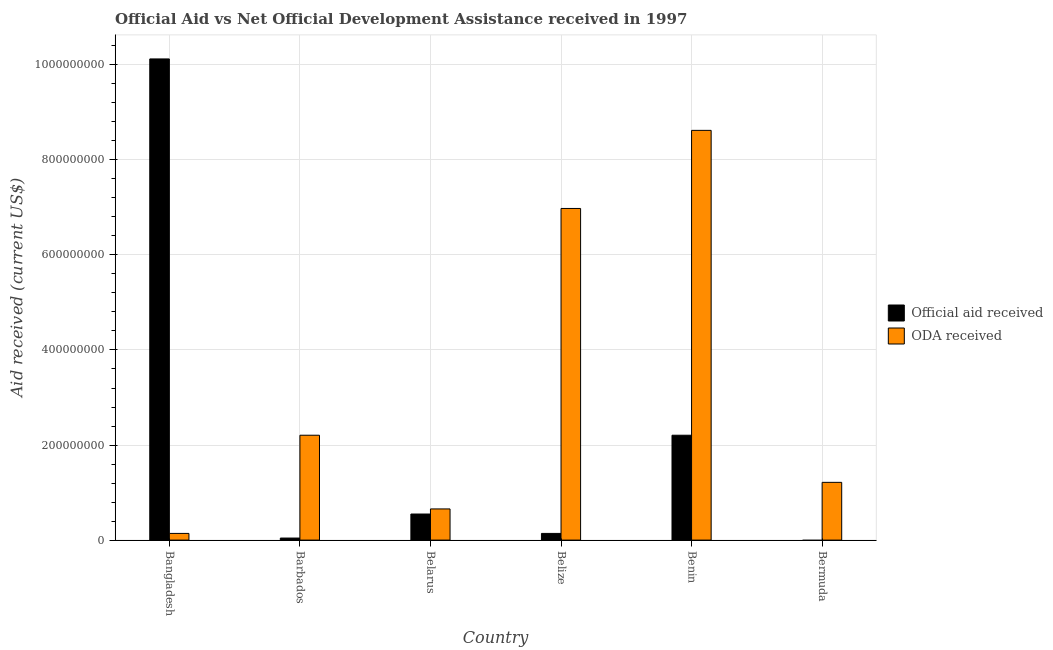How many different coloured bars are there?
Offer a terse response. 2. Are the number of bars per tick equal to the number of legend labels?
Make the answer very short. No. How many bars are there on the 1st tick from the left?
Make the answer very short. 2. How many bars are there on the 5th tick from the right?
Make the answer very short. 2. What is the label of the 4th group of bars from the left?
Give a very brief answer. Belize. What is the oda received in Bermuda?
Give a very brief answer. 1.22e+08. Across all countries, what is the maximum oda received?
Your answer should be very brief. 8.62e+08. What is the total official aid received in the graph?
Your answer should be very brief. 1.31e+09. What is the difference between the oda received in Barbados and that in Bermuda?
Your answer should be very brief. 9.92e+07. What is the difference between the official aid received in Belarus and the oda received in Belize?
Ensure brevity in your answer.  -6.43e+08. What is the average official aid received per country?
Give a very brief answer. 2.18e+08. What is the difference between the official aid received and oda received in Belarus?
Offer a very short reply. -1.07e+07. What is the ratio of the official aid received in Barbados to that in Benin?
Provide a short and direct response. 0.02. Is the oda received in Bangladesh less than that in Bermuda?
Offer a terse response. Yes. Is the difference between the official aid received in Barbados and Belarus greater than the difference between the oda received in Barbados and Belarus?
Provide a short and direct response. No. What is the difference between the highest and the second highest oda received?
Offer a very short reply. 1.64e+08. What is the difference between the highest and the lowest official aid received?
Your answer should be very brief. 1.01e+09. In how many countries, is the official aid received greater than the average official aid received taken over all countries?
Your answer should be very brief. 2. Is the sum of the oda received in Belize and Bermuda greater than the maximum official aid received across all countries?
Your answer should be very brief. No. How many bars are there?
Your response must be concise. 11. How many countries are there in the graph?
Your answer should be very brief. 6. Does the graph contain grids?
Ensure brevity in your answer.  Yes. Where does the legend appear in the graph?
Provide a succinct answer. Center right. How many legend labels are there?
Offer a very short reply. 2. What is the title of the graph?
Keep it short and to the point. Official Aid vs Net Official Development Assistance received in 1997 . Does "Under-5(male)" appear as one of the legend labels in the graph?
Give a very brief answer. No. What is the label or title of the Y-axis?
Ensure brevity in your answer.  Aid received (current US$). What is the Aid received (current US$) in Official aid received in Bangladesh?
Provide a short and direct response. 1.01e+09. What is the Aid received (current US$) of ODA received in Bangladesh?
Provide a short and direct response. 1.41e+07. What is the Aid received (current US$) of Official aid received in Barbados?
Provide a short and direct response. 4.32e+06. What is the Aid received (current US$) in ODA received in Barbados?
Keep it short and to the point. 2.21e+08. What is the Aid received (current US$) in Official aid received in Belarus?
Keep it short and to the point. 5.49e+07. What is the Aid received (current US$) of ODA received in Belarus?
Make the answer very short. 6.56e+07. What is the Aid received (current US$) of Official aid received in Belize?
Your answer should be compact. 1.41e+07. What is the Aid received (current US$) of ODA received in Belize?
Keep it short and to the point. 6.98e+08. What is the Aid received (current US$) of Official aid received in Benin?
Make the answer very short. 2.21e+08. What is the Aid received (current US$) in ODA received in Benin?
Offer a very short reply. 8.62e+08. What is the Aid received (current US$) of ODA received in Bermuda?
Keep it short and to the point. 1.22e+08. Across all countries, what is the maximum Aid received (current US$) of Official aid received?
Your response must be concise. 1.01e+09. Across all countries, what is the maximum Aid received (current US$) in ODA received?
Make the answer very short. 8.62e+08. Across all countries, what is the minimum Aid received (current US$) in ODA received?
Ensure brevity in your answer.  1.41e+07. What is the total Aid received (current US$) of Official aid received in the graph?
Make the answer very short. 1.31e+09. What is the total Aid received (current US$) of ODA received in the graph?
Give a very brief answer. 1.98e+09. What is the difference between the Aid received (current US$) of Official aid received in Bangladesh and that in Barbados?
Offer a very short reply. 1.01e+09. What is the difference between the Aid received (current US$) of ODA received in Bangladesh and that in Barbados?
Your answer should be very brief. -2.07e+08. What is the difference between the Aid received (current US$) in Official aid received in Bangladesh and that in Belarus?
Keep it short and to the point. 9.57e+08. What is the difference between the Aid received (current US$) of ODA received in Bangladesh and that in Belarus?
Your answer should be very brief. -5.15e+07. What is the difference between the Aid received (current US$) in Official aid received in Bangladesh and that in Belize?
Make the answer very short. 9.98e+08. What is the difference between the Aid received (current US$) of ODA received in Bangladesh and that in Belize?
Your answer should be very brief. -6.84e+08. What is the difference between the Aid received (current US$) of Official aid received in Bangladesh and that in Benin?
Provide a short and direct response. 7.92e+08. What is the difference between the Aid received (current US$) of ODA received in Bangladesh and that in Benin?
Provide a succinct answer. -8.48e+08. What is the difference between the Aid received (current US$) in ODA received in Bangladesh and that in Bermuda?
Your answer should be compact. -1.07e+08. What is the difference between the Aid received (current US$) in Official aid received in Barbados and that in Belarus?
Keep it short and to the point. -5.06e+07. What is the difference between the Aid received (current US$) of ODA received in Barbados and that in Belarus?
Your answer should be compact. 1.55e+08. What is the difference between the Aid received (current US$) of Official aid received in Barbados and that in Belize?
Give a very brief answer. -9.74e+06. What is the difference between the Aid received (current US$) in ODA received in Barbados and that in Belize?
Your answer should be compact. -4.77e+08. What is the difference between the Aid received (current US$) in Official aid received in Barbados and that in Benin?
Ensure brevity in your answer.  -2.16e+08. What is the difference between the Aid received (current US$) in ODA received in Barbados and that in Benin?
Your answer should be compact. -6.41e+08. What is the difference between the Aid received (current US$) in ODA received in Barbados and that in Bermuda?
Your answer should be compact. 9.92e+07. What is the difference between the Aid received (current US$) of Official aid received in Belarus and that in Belize?
Provide a succinct answer. 4.08e+07. What is the difference between the Aid received (current US$) of ODA received in Belarus and that in Belize?
Your response must be concise. -6.32e+08. What is the difference between the Aid received (current US$) in Official aid received in Belarus and that in Benin?
Your response must be concise. -1.66e+08. What is the difference between the Aid received (current US$) in ODA received in Belarus and that in Benin?
Give a very brief answer. -7.96e+08. What is the difference between the Aid received (current US$) of ODA received in Belarus and that in Bermuda?
Offer a terse response. -5.59e+07. What is the difference between the Aid received (current US$) of Official aid received in Belize and that in Benin?
Your answer should be very brief. -2.07e+08. What is the difference between the Aid received (current US$) of ODA received in Belize and that in Benin?
Ensure brevity in your answer.  -1.64e+08. What is the difference between the Aid received (current US$) in ODA received in Belize and that in Bermuda?
Keep it short and to the point. 5.76e+08. What is the difference between the Aid received (current US$) of ODA received in Benin and that in Bermuda?
Make the answer very short. 7.41e+08. What is the difference between the Aid received (current US$) in Official aid received in Bangladesh and the Aid received (current US$) in ODA received in Barbados?
Offer a very short reply. 7.92e+08. What is the difference between the Aid received (current US$) in Official aid received in Bangladesh and the Aid received (current US$) in ODA received in Belarus?
Offer a very short reply. 9.47e+08. What is the difference between the Aid received (current US$) of Official aid received in Bangladesh and the Aid received (current US$) of ODA received in Belize?
Your answer should be very brief. 3.15e+08. What is the difference between the Aid received (current US$) of Official aid received in Bangladesh and the Aid received (current US$) of ODA received in Benin?
Give a very brief answer. 1.50e+08. What is the difference between the Aid received (current US$) of Official aid received in Bangladesh and the Aid received (current US$) of ODA received in Bermuda?
Offer a very short reply. 8.91e+08. What is the difference between the Aid received (current US$) in Official aid received in Barbados and the Aid received (current US$) in ODA received in Belarus?
Offer a very short reply. -6.13e+07. What is the difference between the Aid received (current US$) in Official aid received in Barbados and the Aid received (current US$) in ODA received in Belize?
Offer a terse response. -6.93e+08. What is the difference between the Aid received (current US$) in Official aid received in Barbados and the Aid received (current US$) in ODA received in Benin?
Offer a very short reply. -8.58e+08. What is the difference between the Aid received (current US$) of Official aid received in Barbados and the Aid received (current US$) of ODA received in Bermuda?
Offer a very short reply. -1.17e+08. What is the difference between the Aid received (current US$) of Official aid received in Belarus and the Aid received (current US$) of ODA received in Belize?
Give a very brief answer. -6.43e+08. What is the difference between the Aid received (current US$) in Official aid received in Belarus and the Aid received (current US$) in ODA received in Benin?
Provide a succinct answer. -8.07e+08. What is the difference between the Aid received (current US$) of Official aid received in Belarus and the Aid received (current US$) of ODA received in Bermuda?
Your answer should be compact. -6.66e+07. What is the difference between the Aid received (current US$) in Official aid received in Belize and the Aid received (current US$) in ODA received in Benin?
Provide a succinct answer. -8.48e+08. What is the difference between the Aid received (current US$) of Official aid received in Belize and the Aid received (current US$) of ODA received in Bermuda?
Your answer should be compact. -1.07e+08. What is the difference between the Aid received (current US$) in Official aid received in Benin and the Aid received (current US$) in ODA received in Bermuda?
Your answer should be very brief. 9.92e+07. What is the average Aid received (current US$) of Official aid received per country?
Make the answer very short. 2.18e+08. What is the average Aid received (current US$) in ODA received per country?
Offer a very short reply. 3.30e+08. What is the difference between the Aid received (current US$) of Official aid received and Aid received (current US$) of ODA received in Bangladesh?
Ensure brevity in your answer.  9.98e+08. What is the difference between the Aid received (current US$) in Official aid received and Aid received (current US$) in ODA received in Barbados?
Provide a short and direct response. -2.16e+08. What is the difference between the Aid received (current US$) of Official aid received and Aid received (current US$) of ODA received in Belarus?
Your answer should be very brief. -1.07e+07. What is the difference between the Aid received (current US$) of Official aid received and Aid received (current US$) of ODA received in Belize?
Your answer should be very brief. -6.84e+08. What is the difference between the Aid received (current US$) of Official aid received and Aid received (current US$) of ODA received in Benin?
Make the answer very short. -6.41e+08. What is the ratio of the Aid received (current US$) in Official aid received in Bangladesh to that in Barbados?
Provide a succinct answer. 234.34. What is the ratio of the Aid received (current US$) in ODA received in Bangladesh to that in Barbados?
Give a very brief answer. 0.06. What is the ratio of the Aid received (current US$) of Official aid received in Bangladesh to that in Belarus?
Offer a very short reply. 18.45. What is the ratio of the Aid received (current US$) in ODA received in Bangladesh to that in Belarus?
Provide a short and direct response. 0.21. What is the ratio of the Aid received (current US$) in Official aid received in Bangladesh to that in Belize?
Make the answer very short. 72. What is the ratio of the Aid received (current US$) of ODA received in Bangladesh to that in Belize?
Offer a terse response. 0.02. What is the ratio of the Aid received (current US$) in Official aid received in Bangladesh to that in Benin?
Offer a very short reply. 4.59. What is the ratio of the Aid received (current US$) in ODA received in Bangladesh to that in Benin?
Make the answer very short. 0.02. What is the ratio of the Aid received (current US$) of ODA received in Bangladesh to that in Bermuda?
Your response must be concise. 0.12. What is the ratio of the Aid received (current US$) of Official aid received in Barbados to that in Belarus?
Your answer should be compact. 0.08. What is the ratio of the Aid received (current US$) in ODA received in Barbados to that in Belarus?
Your answer should be very brief. 3.36. What is the ratio of the Aid received (current US$) in Official aid received in Barbados to that in Belize?
Offer a terse response. 0.31. What is the ratio of the Aid received (current US$) of ODA received in Barbados to that in Belize?
Your answer should be very brief. 0.32. What is the ratio of the Aid received (current US$) in Official aid received in Barbados to that in Benin?
Offer a very short reply. 0.02. What is the ratio of the Aid received (current US$) of ODA received in Barbados to that in Benin?
Provide a succinct answer. 0.26. What is the ratio of the Aid received (current US$) in ODA received in Barbados to that in Bermuda?
Keep it short and to the point. 1.82. What is the ratio of the Aid received (current US$) in Official aid received in Belarus to that in Belize?
Your response must be concise. 3.9. What is the ratio of the Aid received (current US$) of ODA received in Belarus to that in Belize?
Ensure brevity in your answer.  0.09. What is the ratio of the Aid received (current US$) of Official aid received in Belarus to that in Benin?
Offer a very short reply. 0.25. What is the ratio of the Aid received (current US$) of ODA received in Belarus to that in Benin?
Your answer should be compact. 0.08. What is the ratio of the Aid received (current US$) of ODA received in Belarus to that in Bermuda?
Ensure brevity in your answer.  0.54. What is the ratio of the Aid received (current US$) in Official aid received in Belize to that in Benin?
Ensure brevity in your answer.  0.06. What is the ratio of the Aid received (current US$) of ODA received in Belize to that in Benin?
Your answer should be compact. 0.81. What is the ratio of the Aid received (current US$) of ODA received in Belize to that in Bermuda?
Your answer should be compact. 5.74. What is the ratio of the Aid received (current US$) in ODA received in Benin to that in Bermuda?
Give a very brief answer. 7.1. What is the difference between the highest and the second highest Aid received (current US$) in Official aid received?
Your answer should be compact. 7.92e+08. What is the difference between the highest and the second highest Aid received (current US$) in ODA received?
Provide a short and direct response. 1.64e+08. What is the difference between the highest and the lowest Aid received (current US$) in Official aid received?
Ensure brevity in your answer.  1.01e+09. What is the difference between the highest and the lowest Aid received (current US$) of ODA received?
Provide a succinct answer. 8.48e+08. 